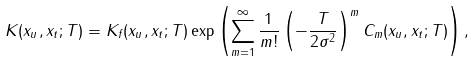<formula> <loc_0><loc_0><loc_500><loc_500>K ( x _ { u } , x _ { t } ; T ) = K _ { f } ( x _ { u } , x _ { t } ; T ) \exp \left ( \sum _ { m = 1 } ^ { \infty } \frac { 1 } { m ! } \left ( - \frac { T } { 2 \sigma ^ { 2 } } \right ) ^ { m } C _ { m } ( x _ { u } , x _ { t } ; T ) \right ) ,</formula> 